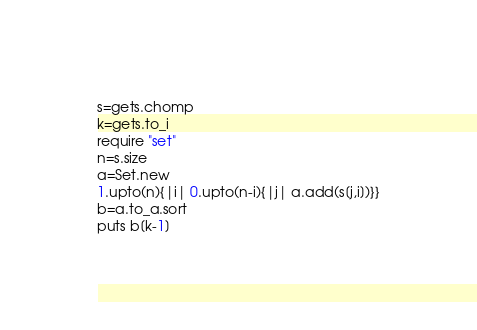Convert code to text. <code><loc_0><loc_0><loc_500><loc_500><_Ruby_>s=gets.chomp
k=gets.to_i
require "set"
n=s.size
a=Set.new
1.upto(n){|i| 0.upto(n-i){|j| a.add(s[j,i])}}
b=a.to_a.sort
puts b[k-1]</code> 